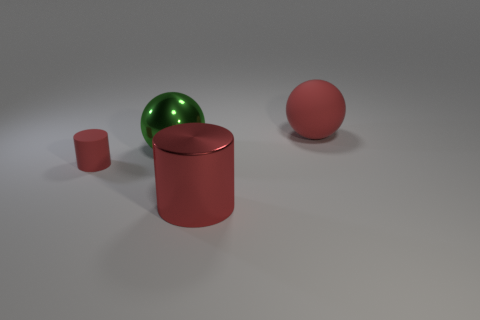There is a rubber object to the left of the large rubber ball; does it have the same color as the large cylinder?
Ensure brevity in your answer.  Yes. There is a large metallic thing that is to the right of the large metal thing to the left of the large metallic cylinder; is there a metal object behind it?
Ensure brevity in your answer.  Yes. Does the sphere that is behind the green object have the same size as the green metal object?
Make the answer very short. Yes. What number of other spheres have the same size as the red rubber ball?
Provide a short and direct response. 1. There is a matte thing that is the same color as the big rubber ball; what is its size?
Offer a terse response. Small. Does the big cylinder have the same color as the small rubber thing?
Offer a very short reply. Yes. The big rubber thing is what shape?
Keep it short and to the point. Sphere. Is there a big matte object that has the same color as the large metal cylinder?
Make the answer very short. Yes. Are there more large objects on the left side of the large red matte object than red metal balls?
Your answer should be compact. Yes. Is the shape of the small object the same as the big thing in front of the big green ball?
Ensure brevity in your answer.  Yes. 